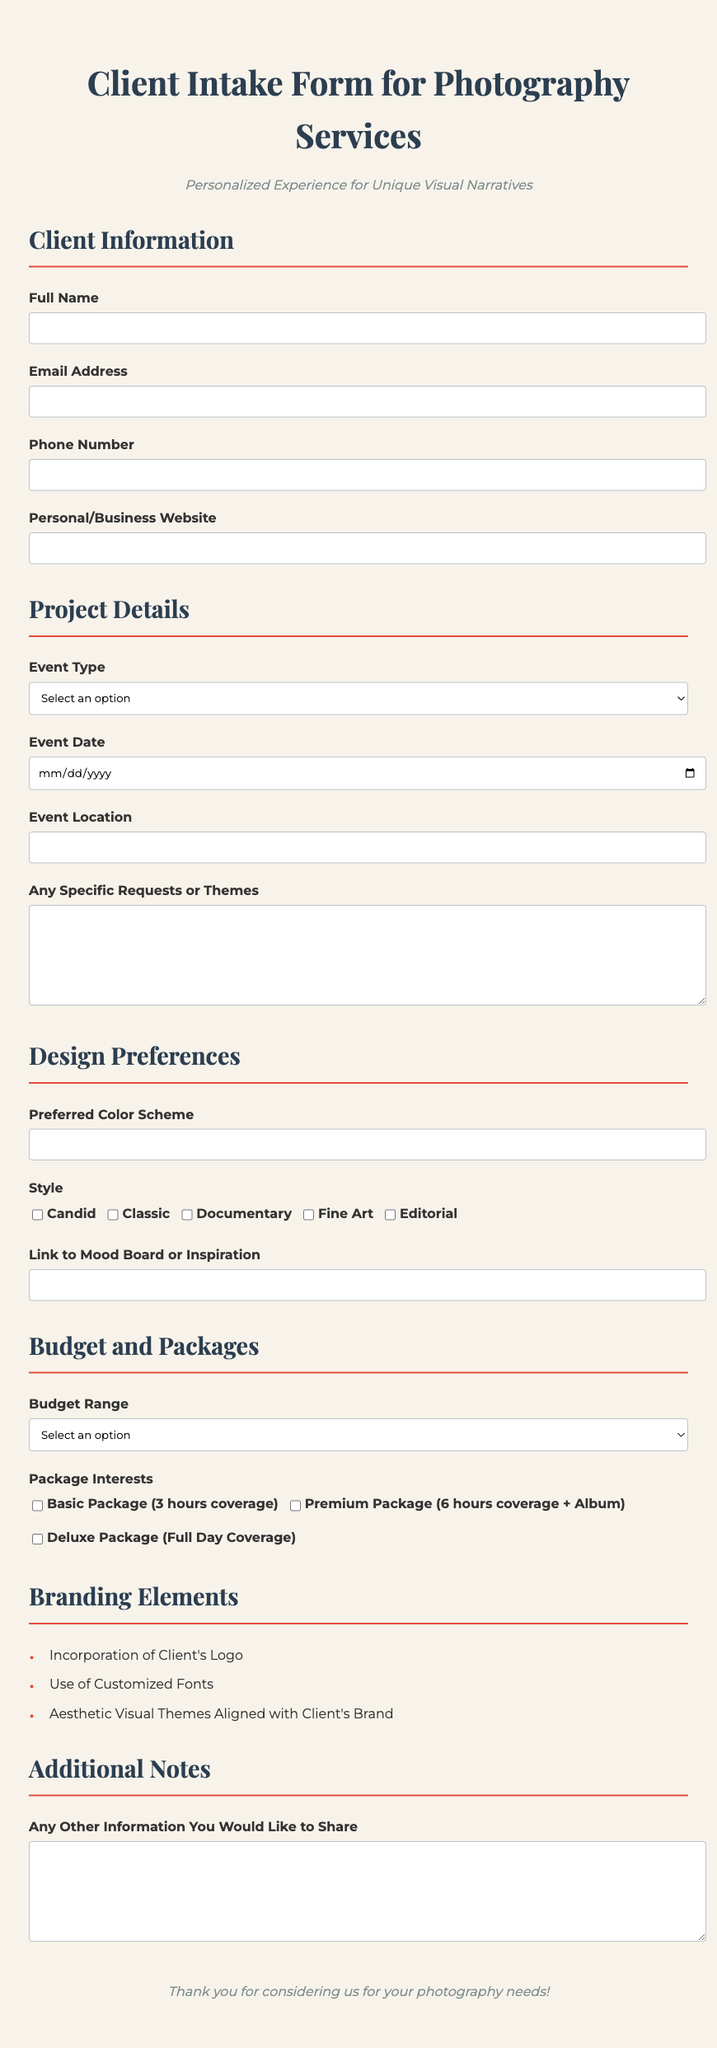what is the title of the form? The title of the form is displayed prominently at the top of the document.
Answer: Client Intake Form for Photography Services who is the target audience for this form? The form is designed for individuals seeking photography services, implying a personalized experience.
Answer: Clients how many event types are listed in the form? The form includes a selection of multiple event types pertinent to photography services.
Answer: Five what is the suggested budget range option that includes the lowest value? The budget range options are clearly outlined in the document, providing various financial categories.
Answer: $500 - $1000 which style options are available for selection? Several photography styles are presented as checkbox options for the client to choose from.
Answer: Candid, Classic, Documentary, Fine Art, Editorial what is the significance of including branding elements in the form? Branding elements enhance the visual narrative of client projects, aligning with their business identity.
Answer: Customization when is the event date required to be provided by the client? The form specifies that the event date is a mandatory input for organizing the photography service.
Answer: Required how many packages are the clients able to choose from? The form categorizes different package offerings for clients looking for photography services.
Answer: Three what is included in the Premium Package? Each package option details the specific services provided, offering clear distinctions among them.
Answer: 6 hours coverage + Album 